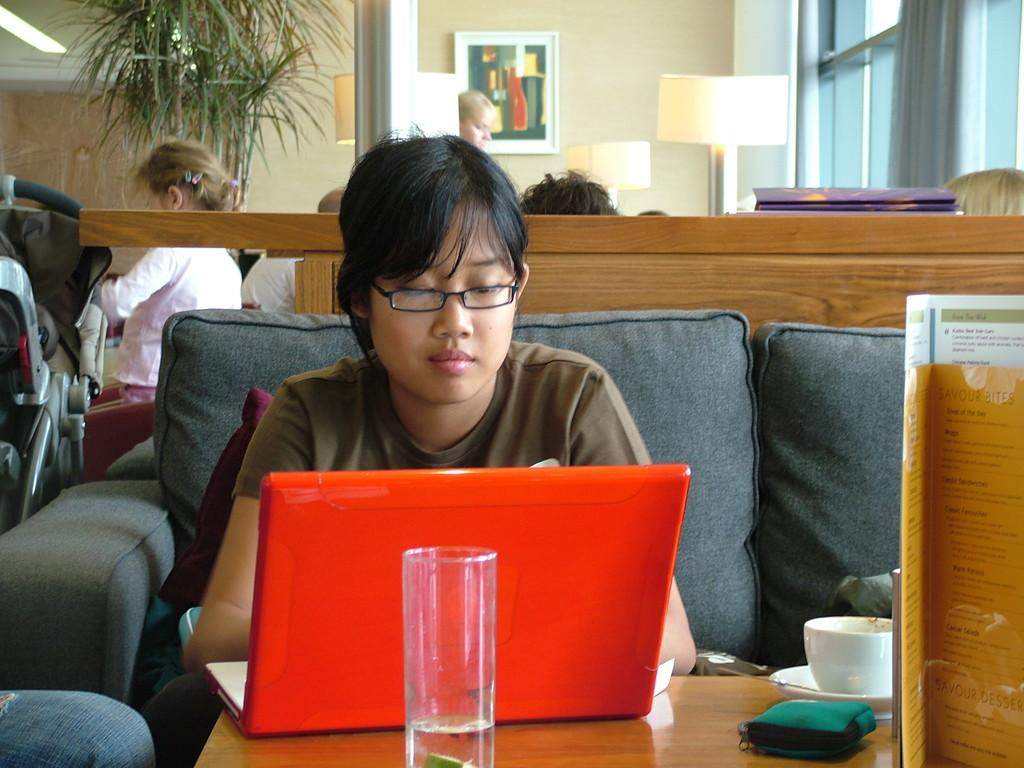What is the person in the image doing? The person is sitting on a sofa. What is the person using while sitting on the sofa? The person is using a red color laptop. What objects are in front of the person? There is a glass and a cup and saucer in front of the person. Are there any other people in the image? Yes, there are other people behind the person. What can be seen in the background of the image? There is a tree and a photo frame visible in the background. Can you see any deer or hills in the image? No, there are no deer or hills present in the image. 